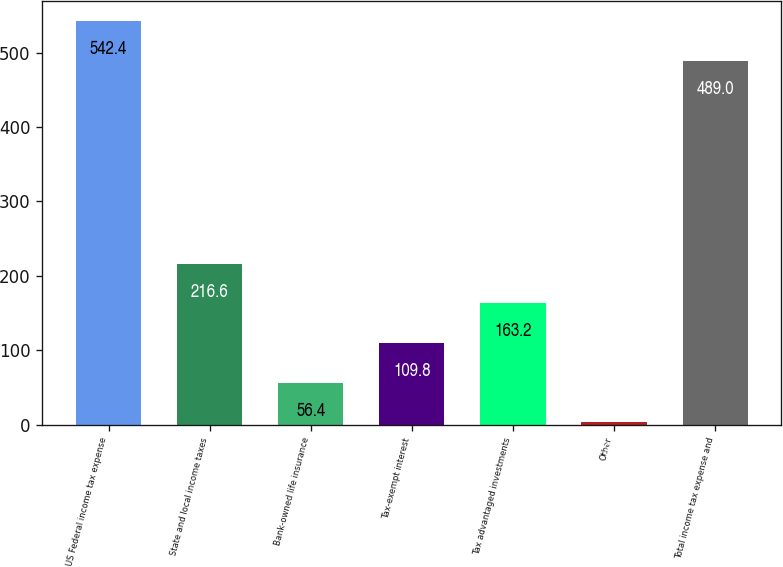Convert chart to OTSL. <chart><loc_0><loc_0><loc_500><loc_500><bar_chart><fcel>US Federal income tax expense<fcel>State and local income taxes<fcel>Bank-owned life insurance<fcel>Tax-exempt interest<fcel>Tax advantaged investments<fcel>Other<fcel>Total income tax expense and<nl><fcel>542.4<fcel>216.6<fcel>56.4<fcel>109.8<fcel>163.2<fcel>3<fcel>489<nl></chart> 